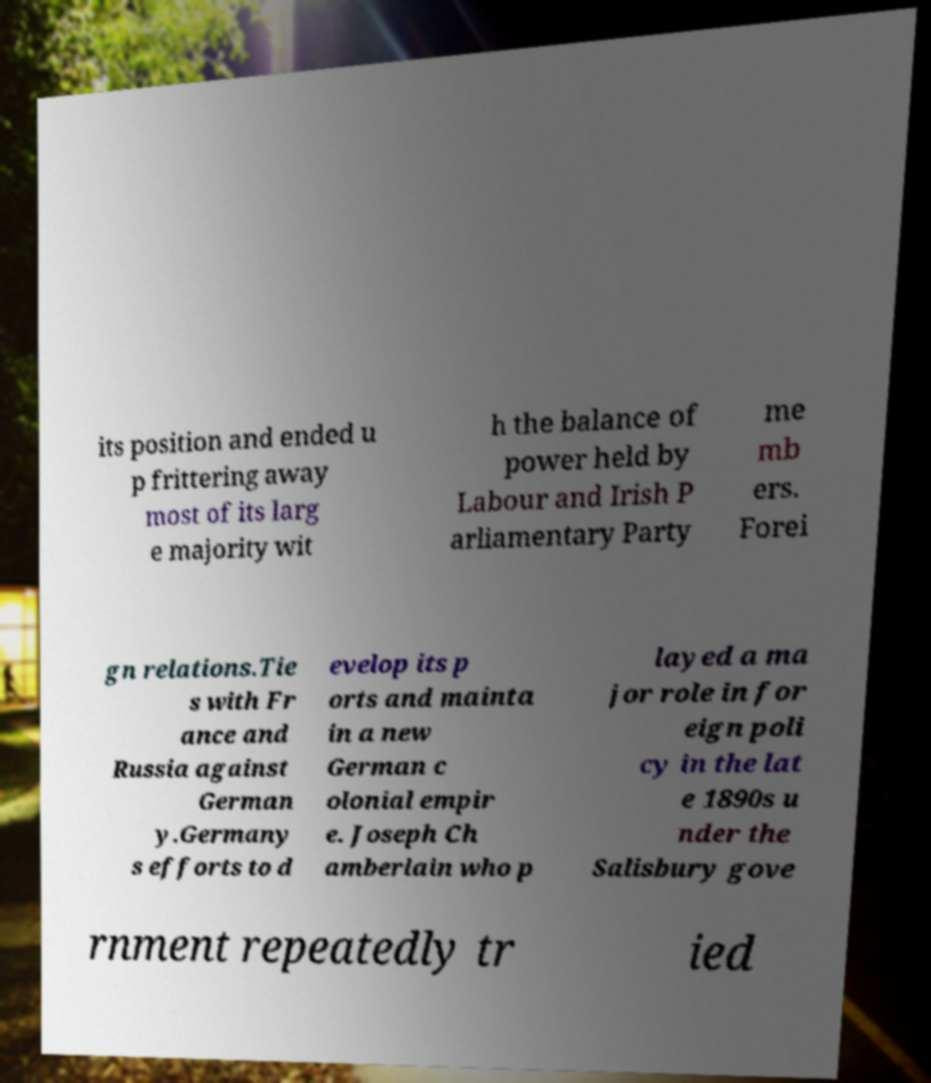Please read and relay the text visible in this image. What does it say? its position and ended u p frittering away most of its larg e majority wit h the balance of power held by Labour and Irish P arliamentary Party me mb ers. Forei gn relations.Tie s with Fr ance and Russia against German y.Germany s efforts to d evelop its p orts and mainta in a new German c olonial empir e. Joseph Ch amberlain who p layed a ma jor role in for eign poli cy in the lat e 1890s u nder the Salisbury gove rnment repeatedly tr ied 